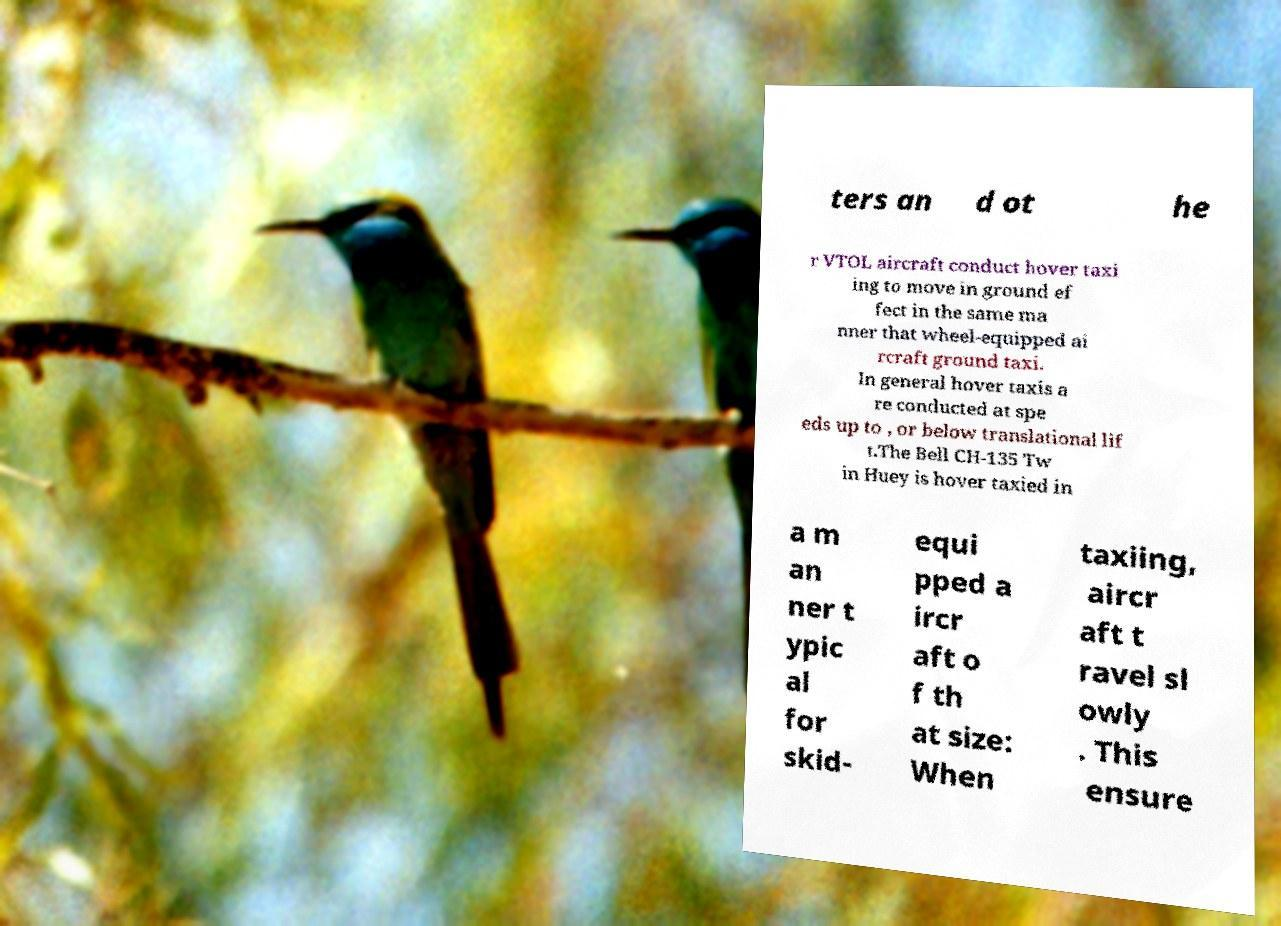Can you accurately transcribe the text from the provided image for me? ters an d ot he r VTOL aircraft conduct hover taxi ing to move in ground ef fect in the same ma nner that wheel-equipped ai rcraft ground taxi. In general hover taxis a re conducted at spe eds up to , or below translational lif t.The Bell CH-135 Tw in Huey is hover taxied in a m an ner t ypic al for skid- equi pped a ircr aft o f th at size: When taxiing, aircr aft t ravel sl owly . This ensure 